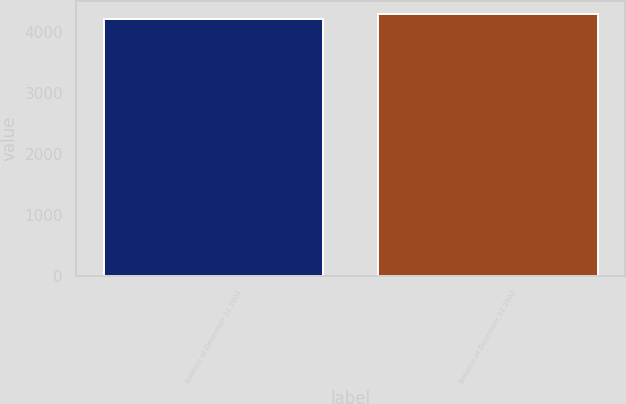<chart> <loc_0><loc_0><loc_500><loc_500><bar_chart><fcel>Balance at December 31 2001<fcel>Balance at December 31 2002<nl><fcel>4210<fcel>4301<nl></chart> 